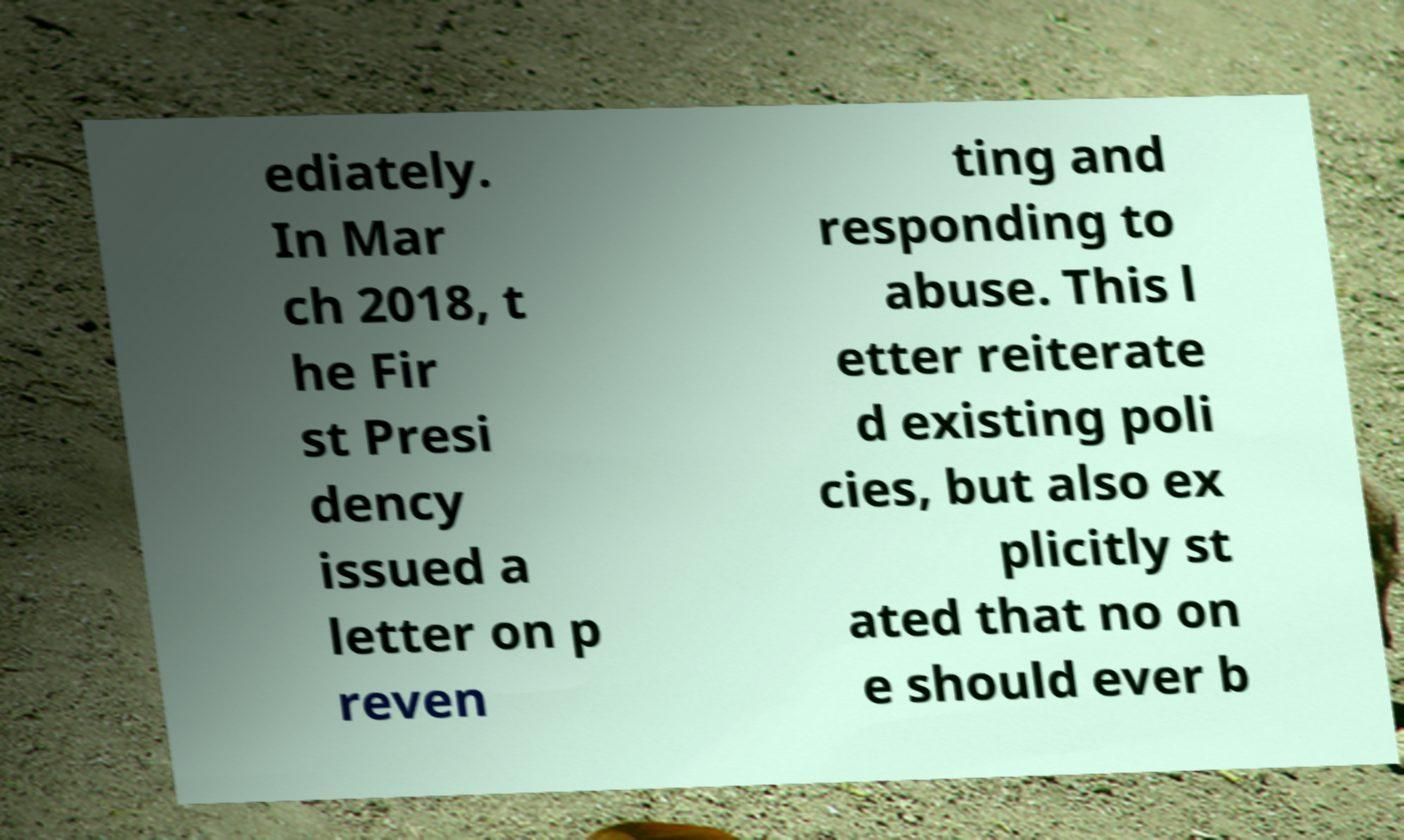What messages or text are displayed in this image? I need them in a readable, typed format. ediately. In Mar ch 2018, t he Fir st Presi dency issued a letter on p reven ting and responding to abuse. This l etter reiterate d existing poli cies, but also ex plicitly st ated that no on e should ever b 